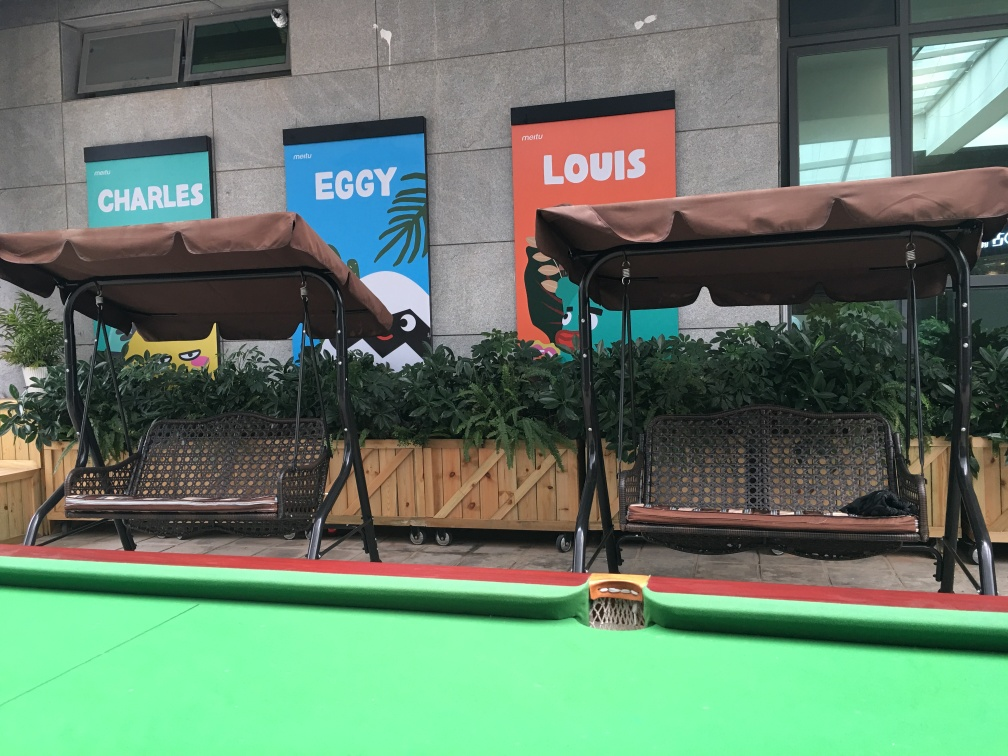What kind of setting is this image portraying? This image shows an outdoor lounge or casual waiting area designed with an element of fun and vibrancy, which could be part of a park, a family entertainment center, or a pet-friendly space owing to the animated signs in the background. Can you tell me more about the signs in the background? The signs featuring 'CHARLES', 'EGGY', and 'LOUIS' are designed with bold colors and playful graphic elements, reminiscent of cartoon or mascot characters. These signs could indicate sections of an establishment, or perhaps they're part of a branding strategy to engage a younger audience or to highlight pet-friendliness. 